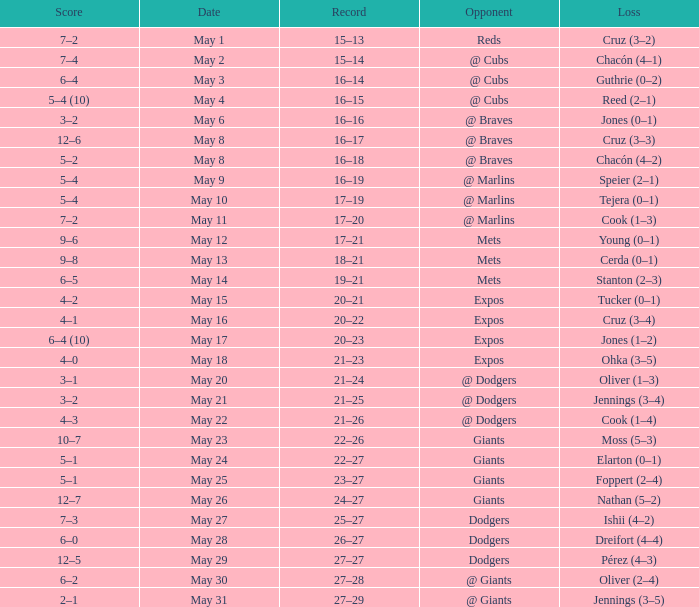Tell me who was the opponent on May 6 @ Braves. 